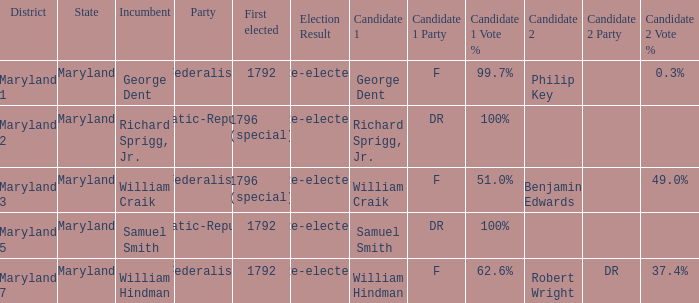Would you be able to parse every entry in this table? {'header': ['District', 'State', 'Incumbent', 'Party', 'First elected', 'Election Result', 'Candidate 1', 'Candidate 1 Party', 'Candidate 1 Vote %', 'Candidate 2', 'Candidate 2 Party', 'Candidate 2 Vote %'], 'rows': [['Maryland 1', 'Maryland', 'George Dent', 'Federalist', '1792', 'Re-elected', 'George Dent', 'F', '99.7%', 'Philip Key', '', '0.3%'], ['Maryland 2', 'Maryland', 'Richard Sprigg, Jr.', 'Democratic-Republican', '1796 (special)', 'Re-elected', 'Richard Sprigg, Jr.', 'DR', '100%', '', '', ''], ['Maryland 3', 'Maryland', 'William Craik', 'Federalist', '1796 (special)', 'Re-elected', 'William Craik', 'F', '51.0%', 'Benjamin Edwards', '', '49.0%'], ['Maryland 5', 'Maryland', 'Samuel Smith', 'Democratic-Republican', '1792', 'Re-elected', 'Samuel Smith', 'DR', '100%', '', '', ''], ['Maryland 7', 'Maryland', 'William Hindman', 'Federalist', '1792', 'Re-elected', 'William Hindman', 'F', '62.6%', 'Robert Wright', 'DR', '37.4%']]} What is the party when the incumbent is samuel smith? Democratic-Republican. 